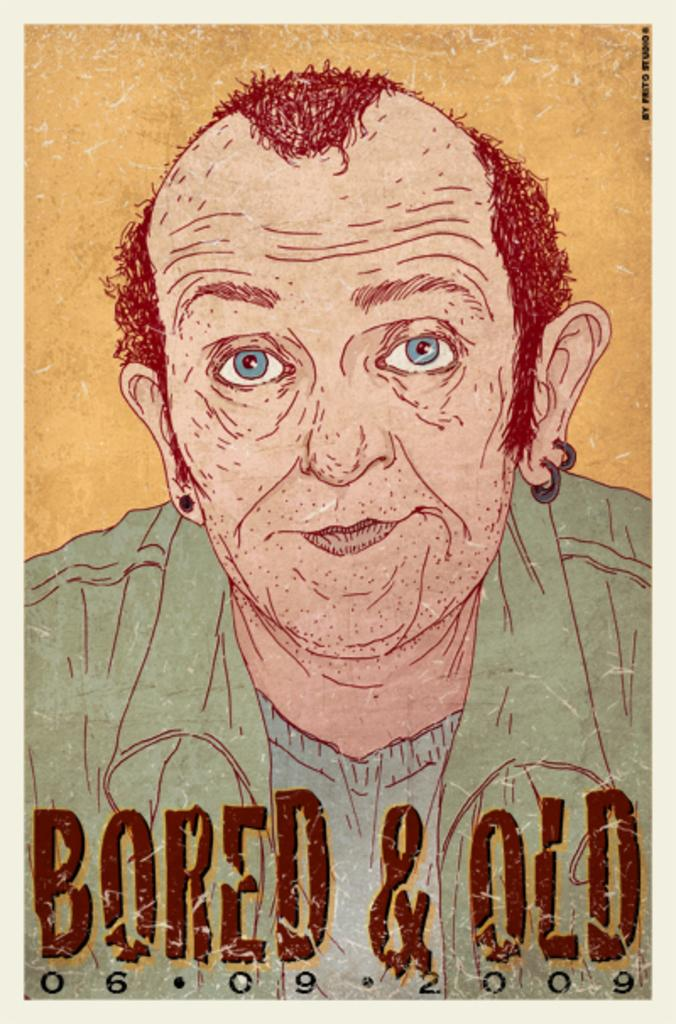<image>
Offer a succinct explanation of the picture presented. A picture of a man with Bored & Old 06.09.2009 written across the bottom. 